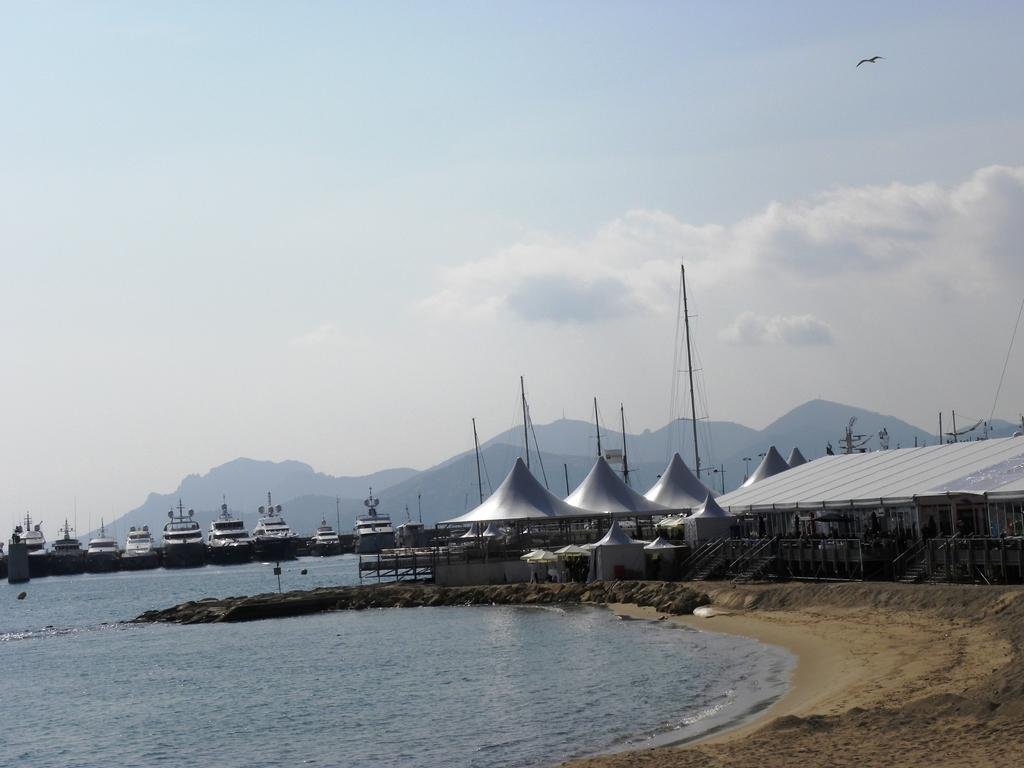What is in the water in the image? There are boats in the water. What type of structure can be seen in the image? There is a house in the image. What objects are present in the water or on the shore? There are poles in the image. How would you describe the sky in the image? The sky is cloudy. What type of animal can be seen in the image? There is a bird flying in the image. What type of cup can be seen on the record in the image? There is no cup or record present in the image. Can you describe the spot where the bird is sitting in the image? The bird is flying, not sitting, in the image. 